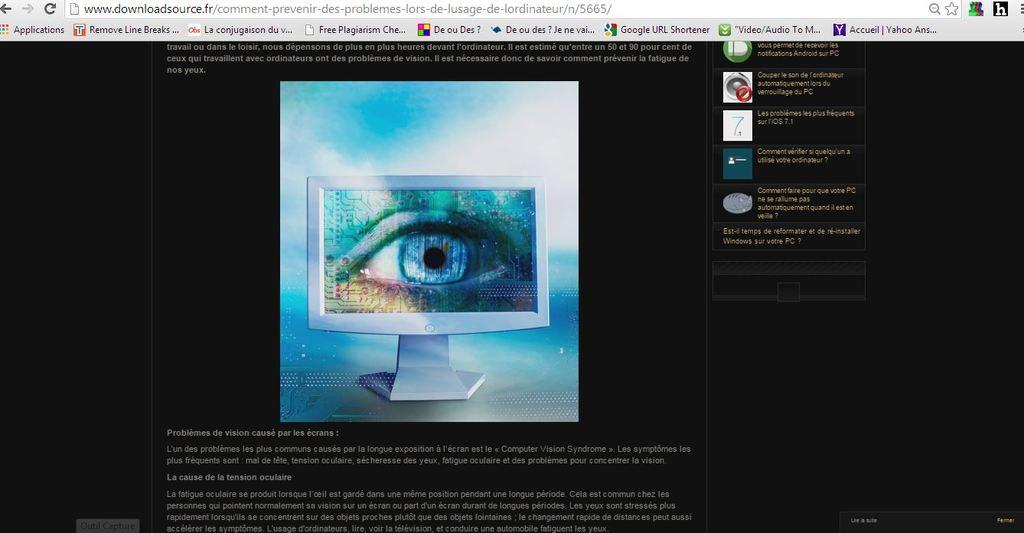<image>
Render a clear and concise summary of the photo. a computer screen that has an eye on it and has a tab that says 'remove line breaks' on it 